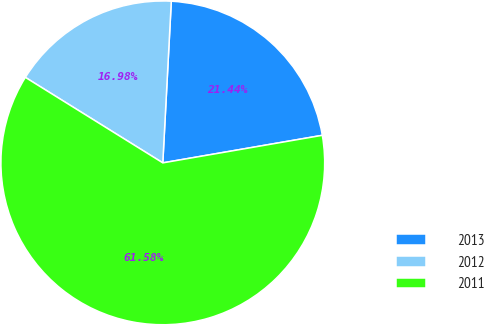Convert chart to OTSL. <chart><loc_0><loc_0><loc_500><loc_500><pie_chart><fcel>2013<fcel>2012<fcel>2011<nl><fcel>21.44%<fcel>16.98%<fcel>61.58%<nl></chart> 